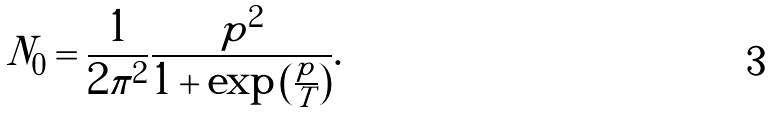Convert formula to latex. <formula><loc_0><loc_0><loc_500><loc_500>N _ { 0 } = \frac { 1 } { 2 \pi ^ { 2 } } \frac { p ^ { 2 } } { 1 + \exp { \left ( \frac { p } { T } \right ) } } .</formula> 